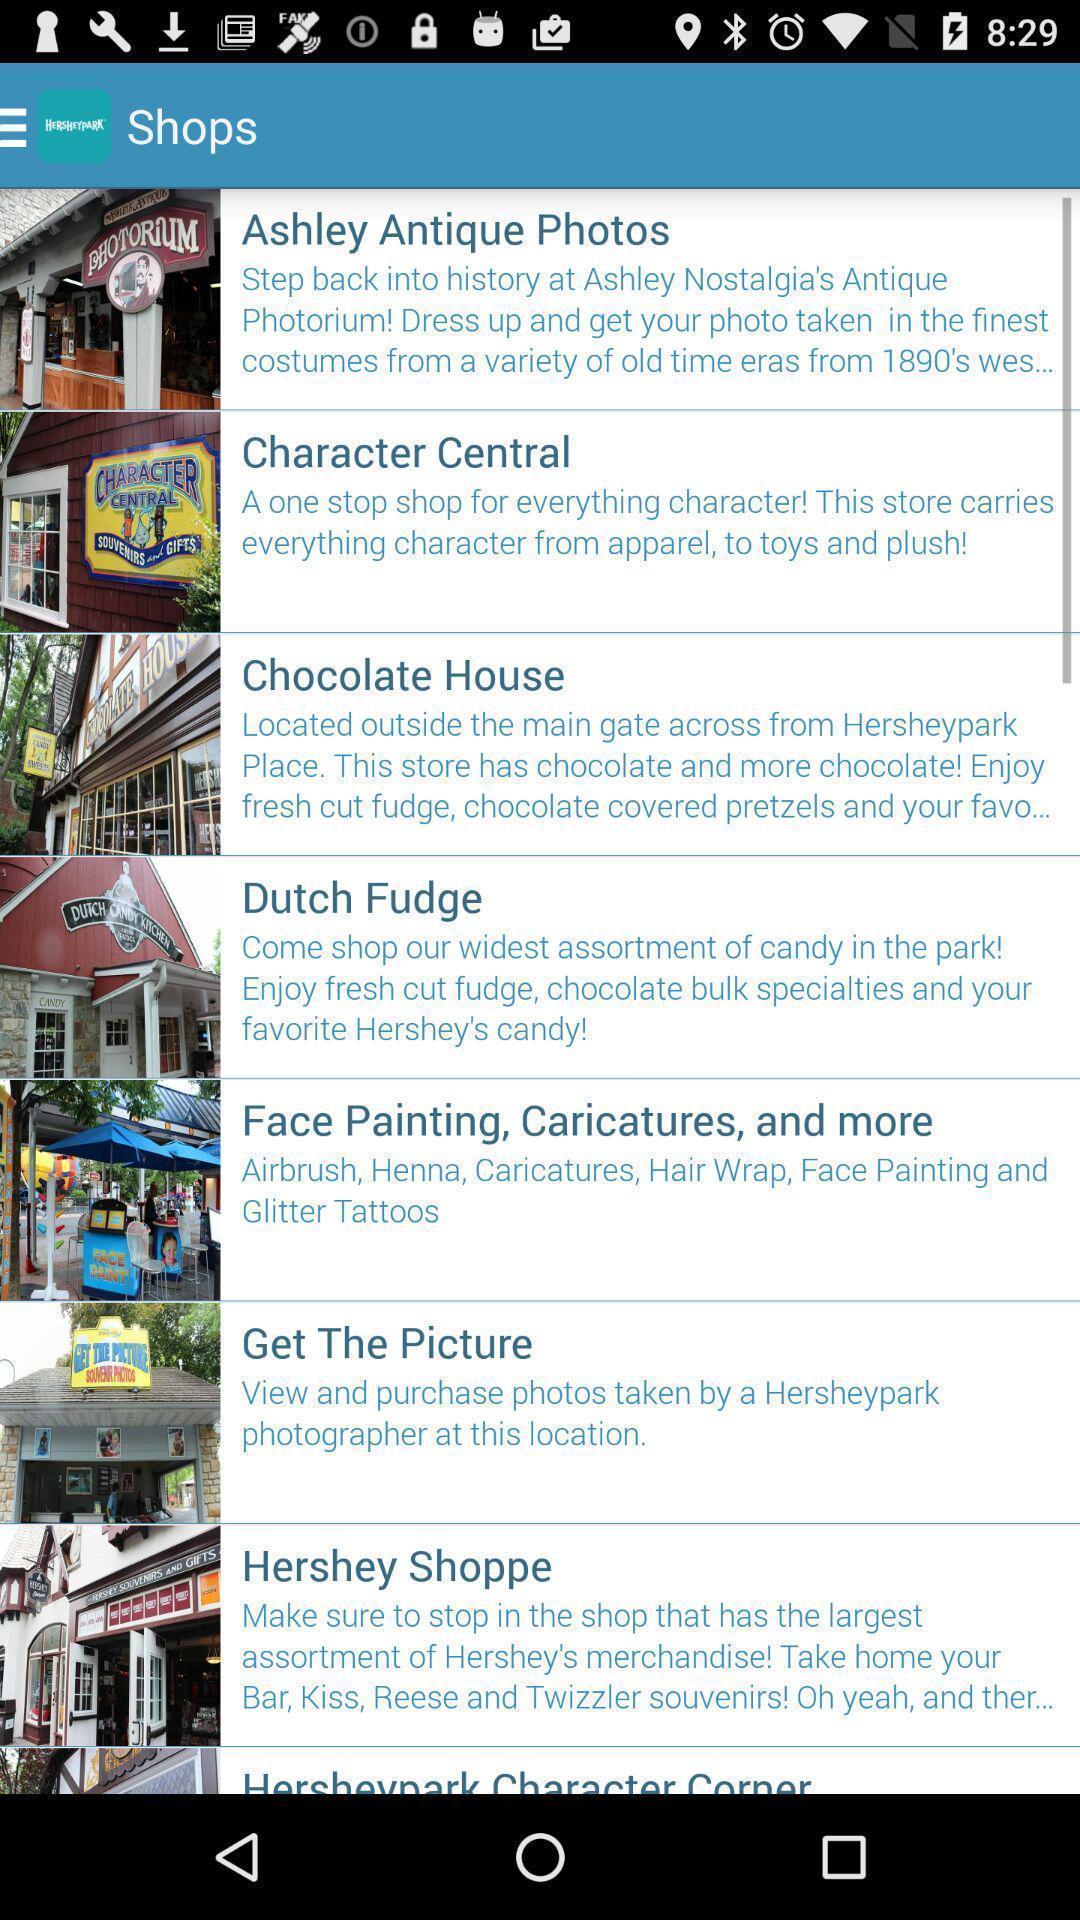Provide a description of this screenshot. Page displaying various list of shops in app. 